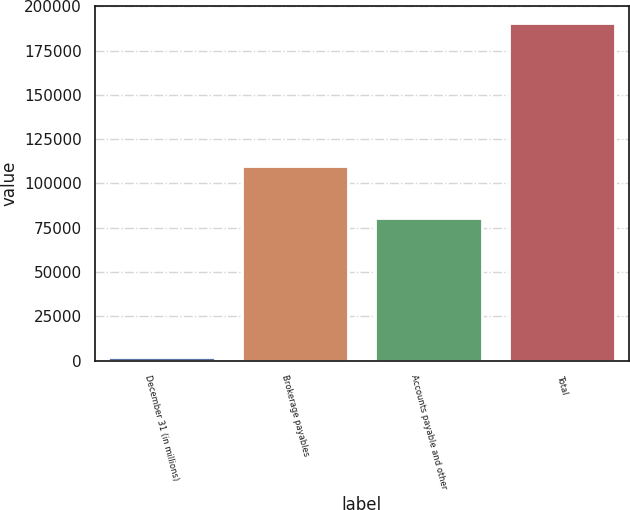<chart> <loc_0><loc_0><loc_500><loc_500><bar_chart><fcel>December 31 (in millions)<fcel>Brokerage payables<fcel>Accounts payable and other<fcel>Total<nl><fcel>2016<fcel>109842<fcel>80701<fcel>190543<nl></chart> 